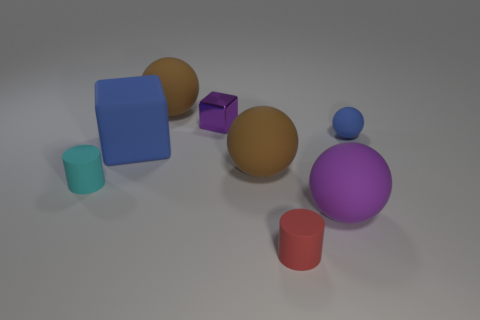What is the shape of the large matte object in front of the tiny cylinder that is on the left side of the rubber thing that is in front of the purple matte sphere?
Give a very brief answer. Sphere. What shape is the thing that is both in front of the tiny sphere and to the right of the small red rubber thing?
Offer a very short reply. Sphere. What number of objects are blue objects or rubber spheres right of the tiny red cylinder?
Your response must be concise. 3. Does the large purple thing have the same material as the small red thing?
Make the answer very short. Yes. How many other objects are there of the same shape as the small blue matte thing?
Ensure brevity in your answer.  3. What is the size of the sphere that is to the left of the large purple sphere and in front of the small shiny thing?
Your response must be concise. Large. How many rubber objects are big things or tiny cylinders?
Give a very brief answer. 6. Do the small rubber thing behind the cyan matte thing and the purple object that is to the left of the big purple matte ball have the same shape?
Make the answer very short. No. Is there a blue object made of the same material as the small cyan cylinder?
Give a very brief answer. Yes. What is the color of the small ball?
Ensure brevity in your answer.  Blue. 